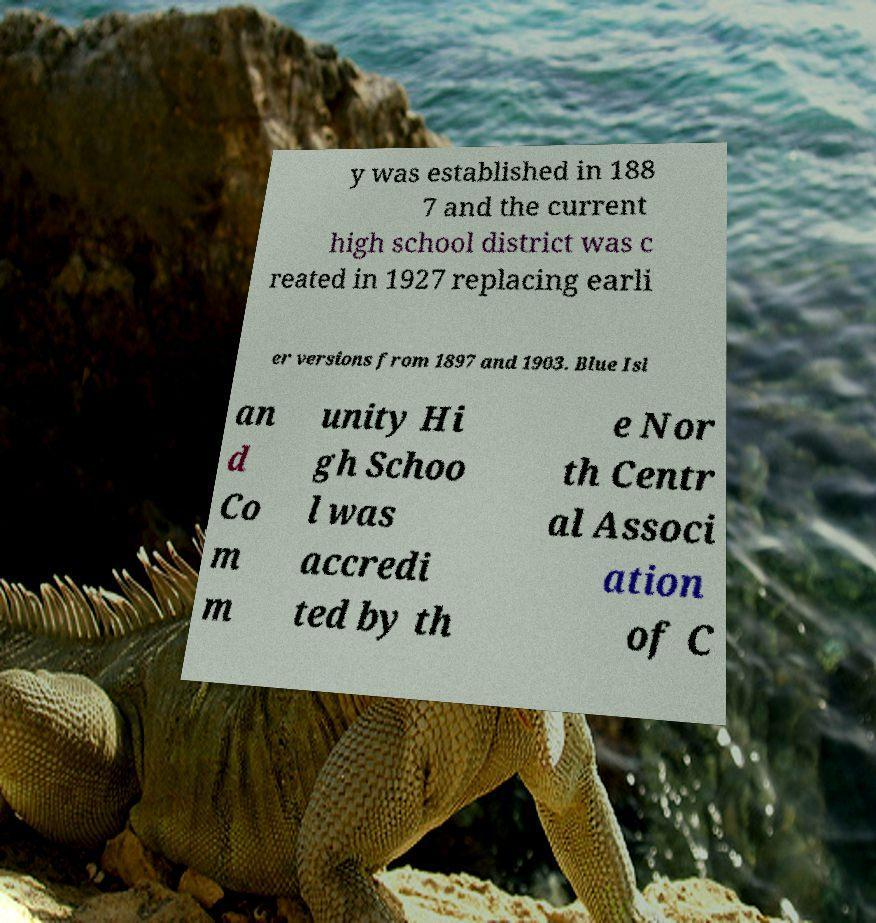Can you read and provide the text displayed in the image?This photo seems to have some interesting text. Can you extract and type it out for me? y was established in 188 7 and the current high school district was c reated in 1927 replacing earli er versions from 1897 and 1903. Blue Isl an d Co m m unity Hi gh Schoo l was accredi ted by th e Nor th Centr al Associ ation of C 